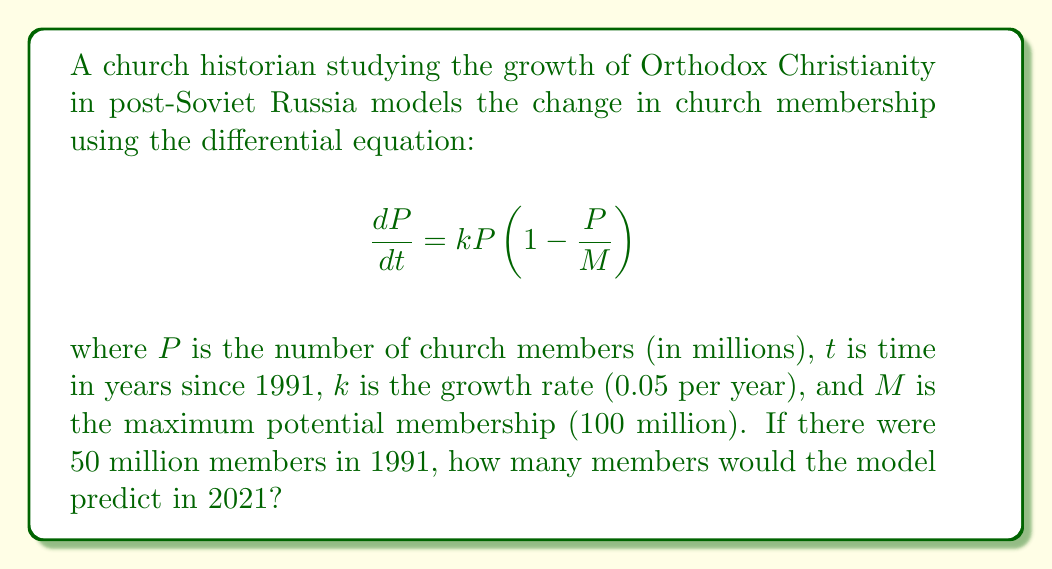Give your solution to this math problem. To solve this problem, we need to follow these steps:

1) The given differential equation is a logistic growth model. Its solution is:

   $$P(t) = \frac{M}{1 + (\frac{M}{P_0} - 1)e^{-kt}}$$

   where $P_0$ is the initial population.

2) We're given:
   $M = 100$ million
   $k = 0.05$ per year
   $P_0 = 50$ million
   $t = 2021 - 1991 = 30$ years

3) Let's substitute these values into the equation:

   $$P(30) = \frac{100}{1 + (\frac{100}{50} - 1)e^{-0.05(30)}}$$

4) Simplify:
   $$P(30) = \frac{100}{1 + e^{-1.5}}$$

5) Calculate:
   $$P(30) \approx 81.76$$

Therefore, the model predicts approximately 81.76 million church members in 2021.
Answer: 81.76 million members 